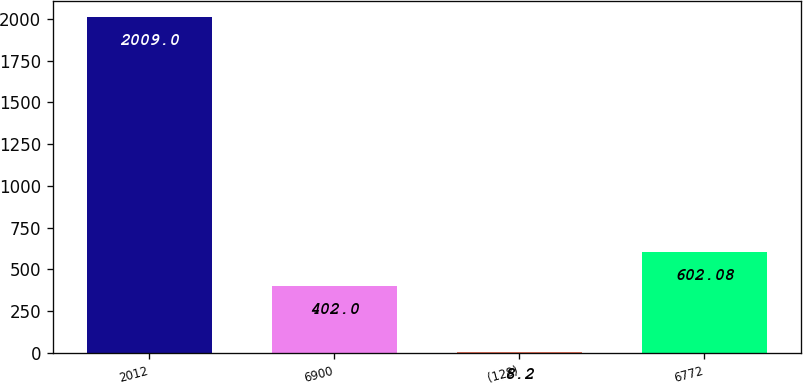<chart> <loc_0><loc_0><loc_500><loc_500><bar_chart><fcel>2012<fcel>6900<fcel>(128)<fcel>6772<nl><fcel>2009<fcel>402<fcel>8.2<fcel>602.08<nl></chart> 